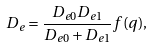Convert formula to latex. <formula><loc_0><loc_0><loc_500><loc_500>D _ { e } = \frac { D _ { e 0 } D _ { e 1 } } { D _ { e 0 } + D _ { e 1 } } f ( q ) ,</formula> 